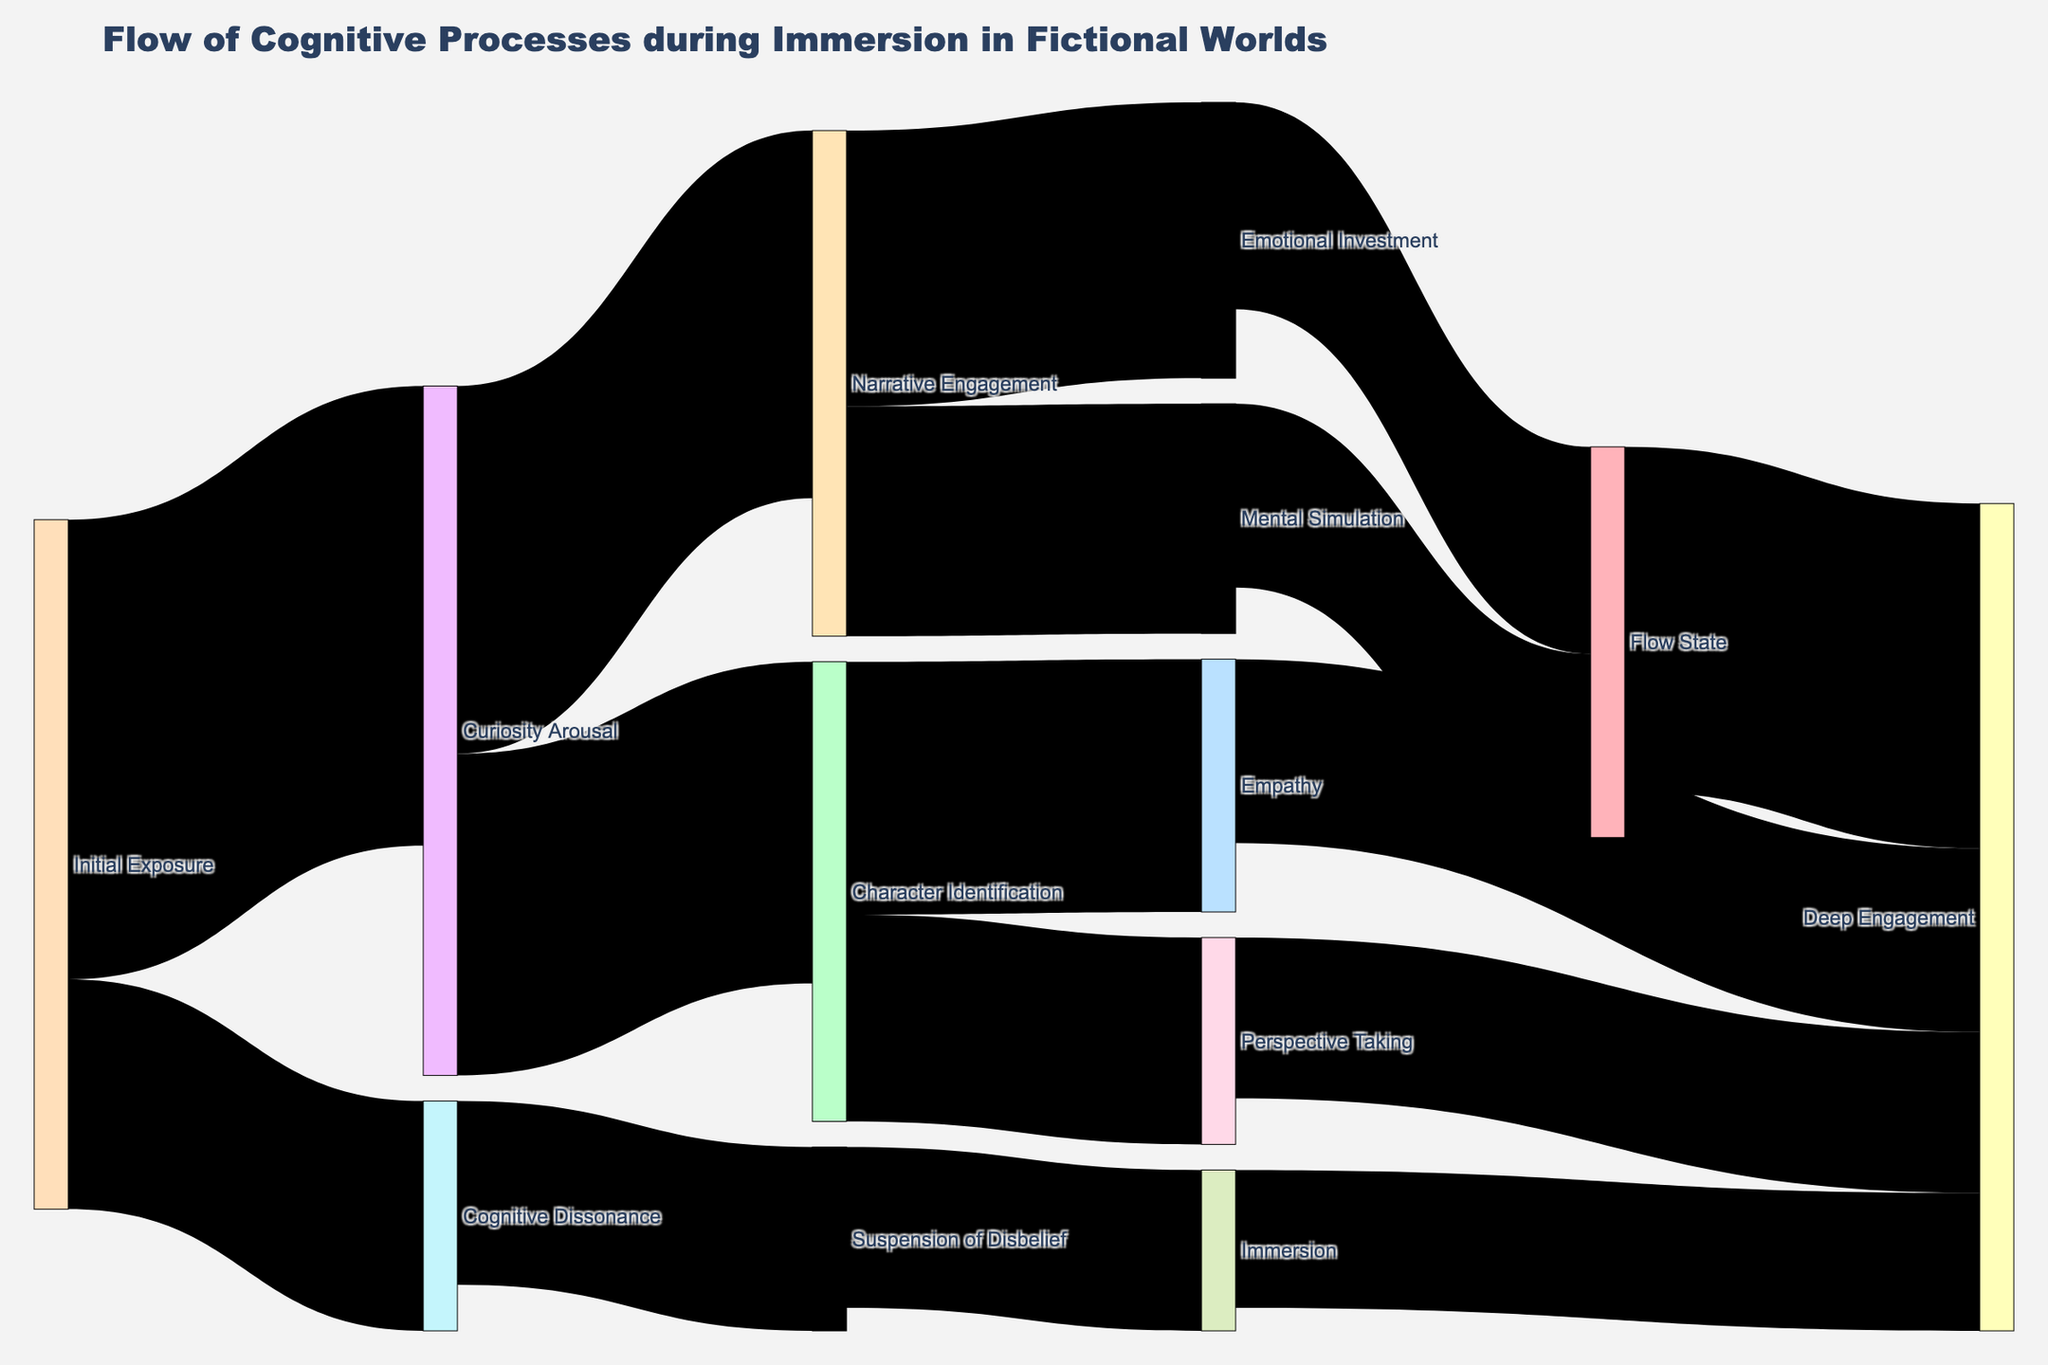What is the first stage in the cognitive process flow during immersion in fictional worlds according to the diagram? The diagram shows that the cognitive process starts with "Initial Exposure."
Answer: Initial Exposure How many cognitive processes lead to "Deep Engagement"? From the diagram, the paths leading to "Deep Engagement" are from "Empathy," "Perspective Taking," "Immersion," and "Flow State," totaling 4 processes.
Answer: 4 Which cognitive process has the highest flow value leading to "Deep Engagement"? The diagram indicates "Flow State" leading to "Deep Engagement" with the highest value of 75.
Answer: Flow State Compare the flow values from "Curiosity Arousal" to "Narrative Engagement" and "Character Identification." Which one is higher? "Curiosity Arousal" to "Narrative Engagement" has a value of 80, while "Curiosity Arousal" to "Character Identification" has a value of 70. Hence, the flow to "Narrative Engagement" is higher.
Answer: Narrative Engagement What are the flow values from "Narrative Engagement" and what do they sum up to? The flows from "Narrative Engagement" are to "Emotional Investment" (60) and "Mental Simulation" (50). Summing them up, 60 + 50 = 110.
Answer: 110 Does "Cognitive Dissonance" lead directly to "Deep Engagement"? From the diagram, "Cognitive Dissonance" leads to "Suspension of Disbelief" and does not have a direct link to "Deep Engagement."
Answer: No What is the total flow value into "Flow State"? "Flow State" receives flows from "Emotional Investment" (45) and "Mental Simulation" (40). The total is 45 + 40 = 85.
Answer: 85 Which cognitive process has an equal flow value to "Deep Engagement" as "Perspective Taking"? "Immersion" leads to "Deep Engagement" with the same value of 30 as "Perspective Taking."
Answer: Immersion How many unique cognitive processes are depicted in the diagram? Counting all distinct labels within the nodes of the diagram, there are 14 unique cognitive processes.
Answer: 14 